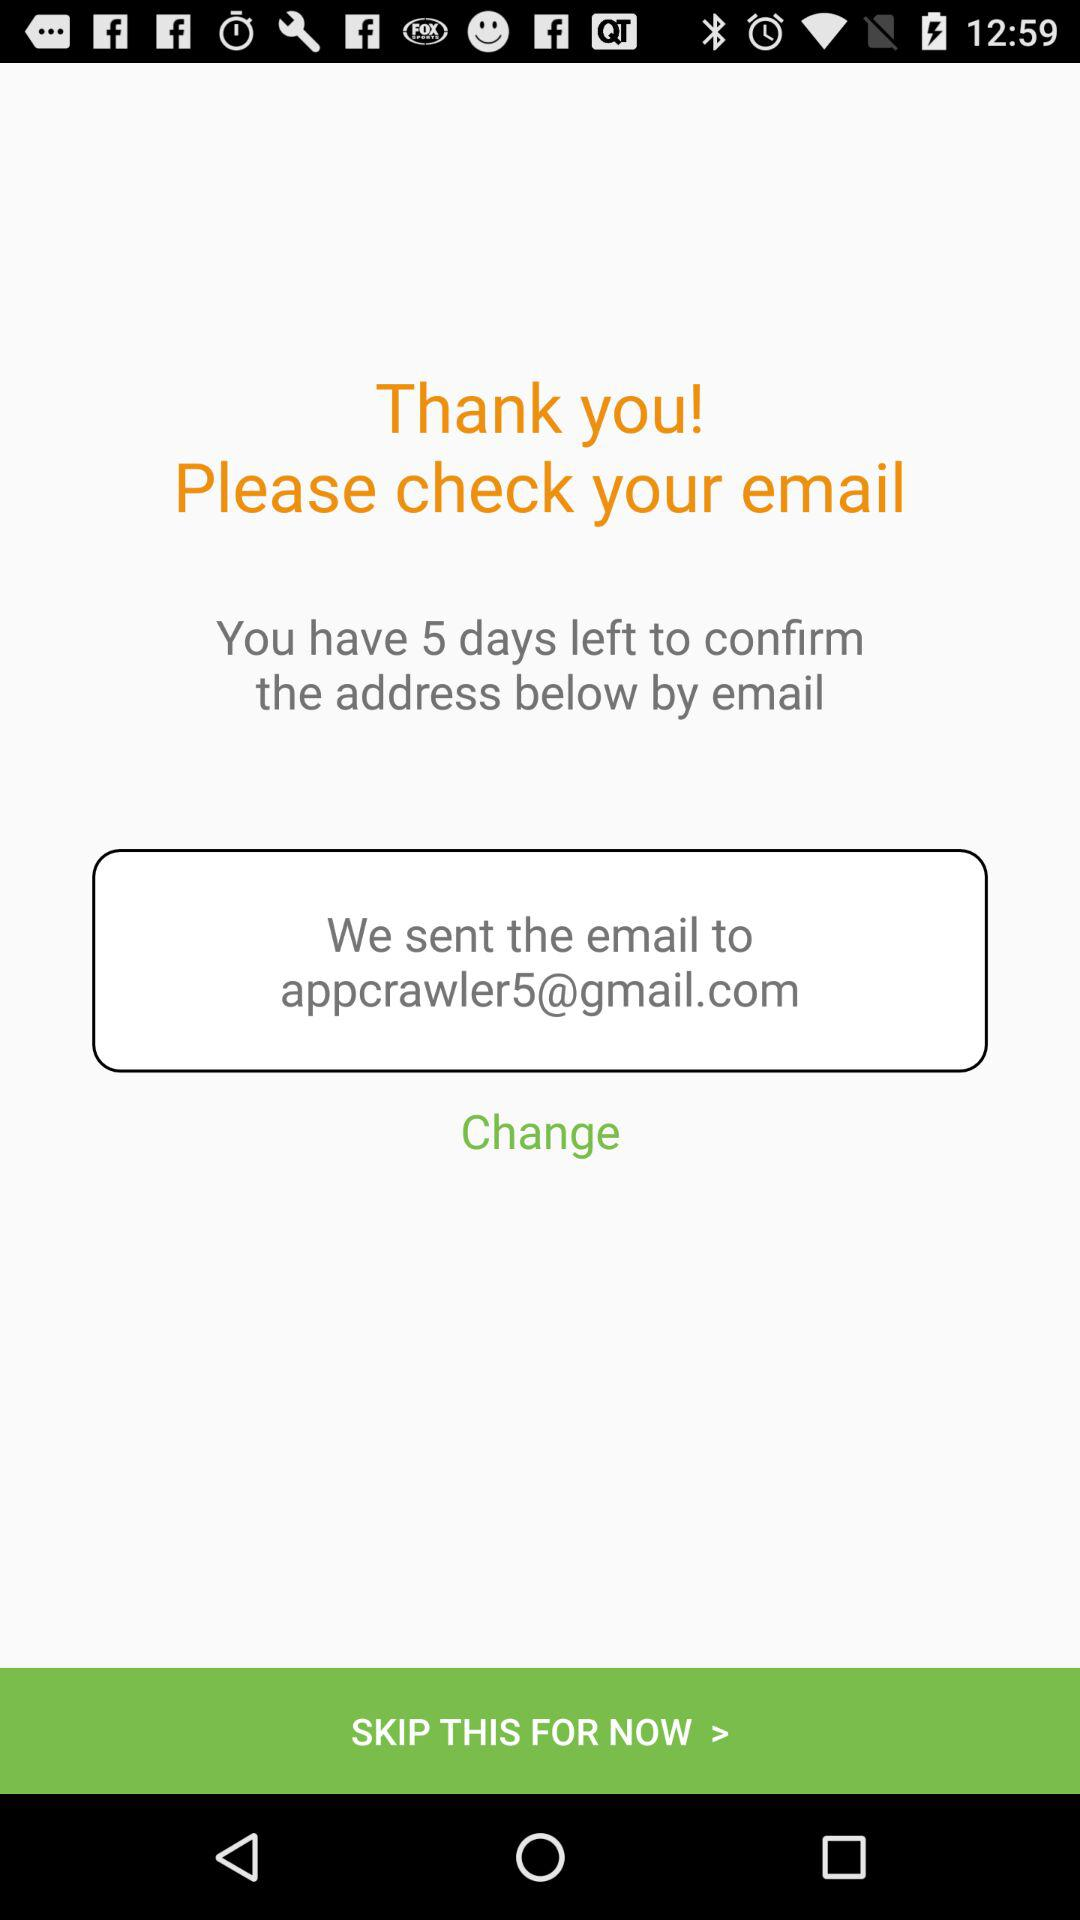At what email address did I receive the address confirmation mail? You received the address confirmation email at appcrawler5@gmail.com. 